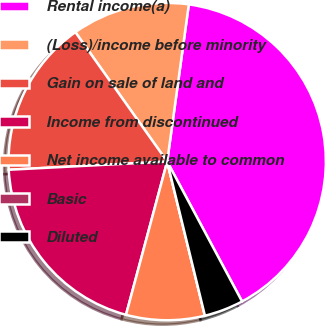Convert chart to OTSL. <chart><loc_0><loc_0><loc_500><loc_500><pie_chart><fcel>Rental income(a)<fcel>(Loss)/income before minority<fcel>Gain on sale of land and<fcel>Income from discontinued<fcel>Net income available to common<fcel>Basic<fcel>Diluted<nl><fcel>40.0%<fcel>12.0%<fcel>16.0%<fcel>20.0%<fcel>8.0%<fcel>0.0%<fcel>4.0%<nl></chart> 